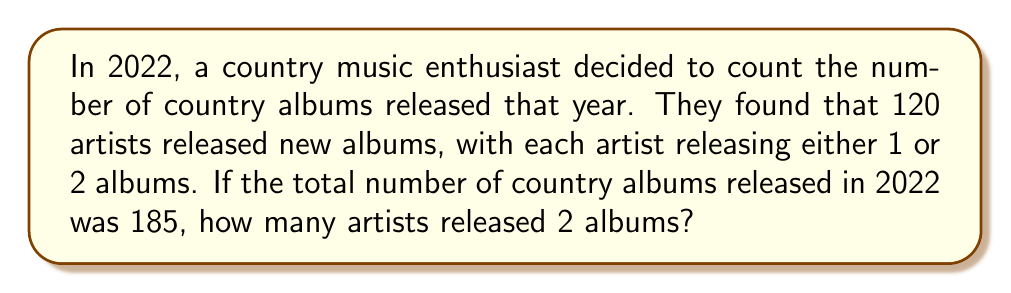Help me with this question. Let's approach this step-by-step:

1) Let $x$ be the number of artists who released 2 albums.
2) Then, $(120 - x)$ is the number of artists who released 1 album.

3) We can set up an equation based on the total number of albums:
   $$(120 - x) \cdot 1 + x \cdot 2 = 185$$

4) Simplify the left side of the equation:
   $$120 - x + 2x = 185$$
   $$120 + x = 185$$

5) Solve for $x$:
   $$x = 185 - 120 = 65$$

Therefore, 65 artists released 2 albums in 2022.

To verify:
- 65 artists released 2 albums: $65 \cdot 2 = 130$ albums
- 55 artists (120 - 65) released 1 album: $55 \cdot 1 = 55$ albums
- Total: $130 + 55 = 185$ albums, which matches the given information.
Answer: 65 artists released 2 albums in 2022. 